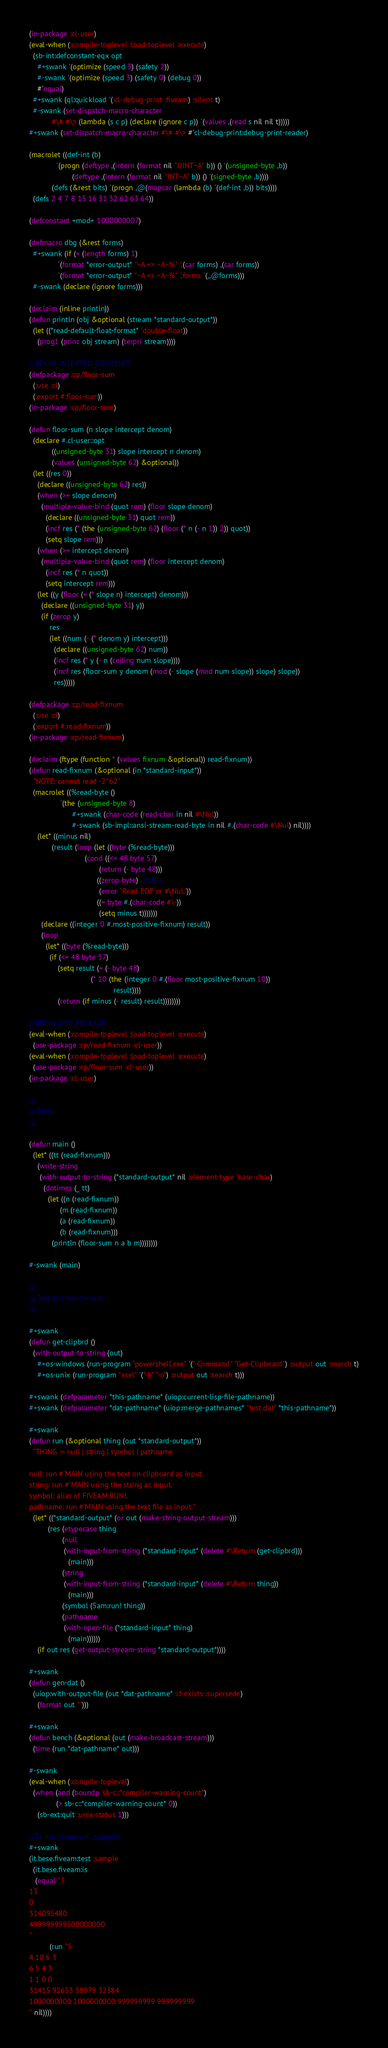<code> <loc_0><loc_0><loc_500><loc_500><_Lisp_>(in-package :cl-user)
(eval-when (:compile-toplevel :load-toplevel :execute)
  (sb-int:defconstant-eqx opt
    #+swank '(optimize (speed 3) (safety 2))
    #-swank '(optimize (speed 3) (safety 0) (debug 0))
    #'equal)
  #+swank (ql:quickload '(:cl-debug-print :fiveam) :silent t)
  #-swank (set-dispatch-macro-character
           #\# #\> (lambda (s c p) (declare (ignore c p)) `(values ,(read s nil nil t)))))
#+swank (set-dispatch-macro-character #\# #\> #'cl-debug-print:debug-print-reader)

(macrolet ((def-int (b)
             `(progn (deftype ,(intern (format nil "UINT~A" b)) () '(unsigned-byte ,b))
                     (deftype ,(intern (format nil "INT~A" b)) () '(signed-byte ,b))))
           (defs (&rest bits) `(progn ,@(mapcar (lambda (b) `(def-int ,b)) bits))))
  (defs 2 4 7 8 15 16 31 32 62 63 64))

(defconstant +mod+ 1000000007)

(defmacro dbg (&rest forms)
  #+swank (if (= (length forms) 1)
              `(format *error-output* "~A => ~A~%" ',(car forms) ,(car forms))
              `(format *error-output* "~A => ~A~%" ',forms `(,,@forms)))
  #-swank (declare (ignore forms)))

(declaim (inline println))
(defun println (obj &optional (stream *standard-output*))
  (let ((*read-default-float-format* 'double-float))
    (prog1 (princ obj stream) (terpri stream))))

;; BEGIN_INSERTED_CONTENTS
(defpackage :cp/floor-sum
  (:use :cl)
  (:export #:floor-sum))
(in-package :cp/floor-sum)

(defun floor-sum (n slope intercept denom)
  (declare #.cl-user::opt
           ((unsigned-byte 31) slope intercept n denom)
           (values (unsigned-byte 62) &optional))
  (let ((res 0))
    (declare ((unsigned-byte 62) res))
    (when (>= slope denom)
      (multiple-value-bind (quot rem) (floor slope denom)
        (declare ((unsigned-byte 31) quot rem))
        (incf res (* (the (unsigned-byte 62) (floor (* n (- n 1)) 2)) quot))
        (setq slope rem)))
    (when (>= intercept denom)
      (multiple-value-bind (quot rem) (floor intercept denom)
        (incf res (* n quot))
        (setq intercept rem)))
    (let ((y (floor (+ (* slope n) intercept) denom)))
      (declare ((unsigned-byte 31) y))
      (if (zerop y)
          res
          (let ((num (- (* denom y) intercept)))
            (declare ((unsigned-byte 62) num))
            (incf res (* y (- n (ceiling num slope))))
            (incf res (floor-sum y denom (mod (- slope (mod num slope)) slope) slope))
            res)))))

(defpackage :cp/read-fixnum
  (:use :cl)
  (:export #:read-fixnum))
(in-package :cp/read-fixnum)

(declaim (ftype (function * (values fixnum &optional)) read-fixnum))
(defun read-fixnum (&optional (in *standard-input*))
  "NOTE: cannot read -2^62"
  (macrolet ((%read-byte ()
               `(the (unsigned-byte 8)
                     #+swank (char-code (read-char in nil #\Nul))
                     #-swank (sb-impl::ansi-stream-read-byte in nil #.(char-code #\Nul) nil))))
    (let* ((minus nil)
           (result (loop (let ((byte (%read-byte)))
                           (cond ((<= 48 byte 57)
                                  (return (- byte 48)))
                                 ((zerop byte) ; #\Nul
                                  (error "Read EOF or #\Nul."))
                                 ((= byte #.(char-code #\-))
                                  (setq minus t)))))))
      (declare ((integer 0 #.most-positive-fixnum) result))
      (loop
        (let* ((byte (%read-byte)))
          (if (<= 48 byte 57)
              (setq result (+ (- byte 48)
                              (* 10 (the (integer 0 #.(floor most-positive-fixnum 10))
                                         result))))
              (return (if minus (- result) result))))))))

;; BEGIN_USE_PACKAGE
(eval-when (:compile-toplevel :load-toplevel :execute)
  (use-package :cp/read-fixnum :cl-user))
(eval-when (:compile-toplevel :load-toplevel :execute)
  (use-package :cp/floor-sum :cl-user))
(in-package :cl-user)

;;;
;;; Body
;;;

(defun main ()
  (let* ((tt (read-fixnum)))
    (write-string
     (with-output-to-string (*standard-output* nil :element-type 'base-char)
       (dotimes (_ tt)
         (let ((n (read-fixnum))
               (m (read-fixnum))
               (a (read-fixnum))
               (b (read-fixnum)))
           (println (floor-sum n a b m))))))))

#-swank (main)

;;;
;;; Test and benchmark
;;;

#+swank
(defun get-clipbrd ()
  (with-output-to-string (out)
    #+os-windows (run-program "powershell.exe" '("-Command" "Get-Clipboard") :output out :search t)
    #+os-unix (run-program "xsel" '("-b" "-o") :output out :search t)))

#+swank (defparameter *this-pathname* (uiop:current-lisp-file-pathname))
#+swank (defparameter *dat-pathname* (uiop:merge-pathnames* "test.dat" *this-pathname*))

#+swank
(defun run (&optional thing (out *standard-output*))
  "THING := null | string | symbol | pathname

null: run #'MAIN using the text on clipboard as input.
string: run #'MAIN using the string as input.
symbol: alias of FIVEAM:RUN!.
pathname: run #'MAIN using the text file as input."
  (let* ((*standard-output* (or out (make-string-output-stream)))
         (res (etypecase thing
                (null
                 (with-input-from-string (*standard-input* (delete #\Return (get-clipbrd)))
                   (main)))
                (string
                 (with-input-from-string (*standard-input* (delete #\Return thing))
                   (main)))
                (symbol (5am:run! thing))
                (pathname
                 (with-open-file (*standard-input* thing)
                   (main))))))
    (if out res (get-output-stream-string *standard-output*))))

#+swank
(defun gen-dat ()
  (uiop:with-output-file (out *dat-pathname* :if-exists :supersede)
    (format out "")))

#+swank
(defun bench (&optional (out (make-broadcast-stream)))
  (time (run *dat-pathname* out)))

#-swank
(eval-when (:compile-toplevel)
  (when (and (boundp 'sb-c::*compiler-warning-count*)
             (> sb-c::*compiler-warning-count* 0))
    (sb-ext:quit :unix-status 1)))

;; To run: (5am:run! :sample)
#+swank
(it.bese.fiveam:test :sample
  (it.bese.fiveam:is
   (equal "3
13
0
314095480
499999999500000000
"
          (run "5
4 10 6 3
6 5 4 3
1 1 0 0
31415 92653 58979 32384
1000000000 1000000000 999999999 999999999
" nil))))
</code> 